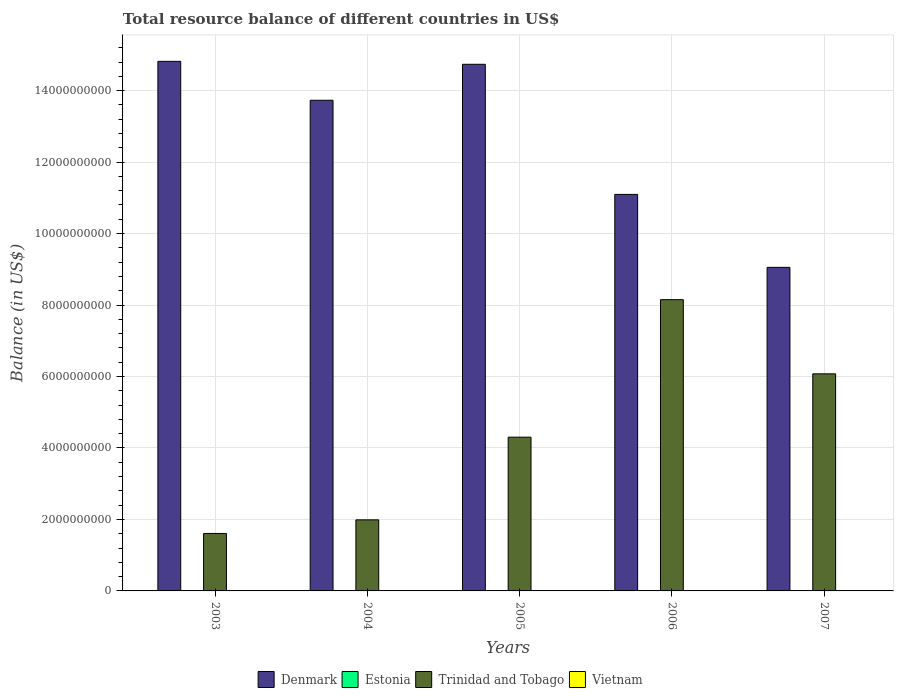How many groups of bars are there?
Offer a very short reply. 5. Are the number of bars per tick equal to the number of legend labels?
Your answer should be very brief. No. How many bars are there on the 1st tick from the right?
Give a very brief answer. 2. What is the total resource balance in Denmark in 2005?
Provide a succinct answer. 1.47e+1. Across all years, what is the minimum total resource balance in Vietnam?
Provide a succinct answer. 0. In which year was the total resource balance in Trinidad and Tobago maximum?
Your response must be concise. 2006. What is the total total resource balance in Denmark in the graph?
Keep it short and to the point. 6.34e+1. What is the difference between the total resource balance in Denmark in 2003 and that in 2004?
Make the answer very short. 1.09e+09. What is the difference between the total resource balance in Trinidad and Tobago in 2006 and the total resource balance in Denmark in 2004?
Your answer should be compact. -5.58e+09. What is the average total resource balance in Denmark per year?
Make the answer very short. 1.27e+1. In the year 2004, what is the difference between the total resource balance in Denmark and total resource balance in Trinidad and Tobago?
Keep it short and to the point. 1.17e+1. What is the ratio of the total resource balance in Trinidad and Tobago in 2003 to that in 2006?
Your response must be concise. 0.2. Is the total resource balance in Denmark in 2004 less than that in 2005?
Make the answer very short. Yes. What is the difference between the highest and the second highest total resource balance in Denmark?
Provide a succinct answer. 8.19e+07. What is the difference between the highest and the lowest total resource balance in Trinidad and Tobago?
Your answer should be compact. 6.54e+09. Is the sum of the total resource balance in Trinidad and Tobago in 2003 and 2005 greater than the maximum total resource balance in Estonia across all years?
Make the answer very short. Yes. Is it the case that in every year, the sum of the total resource balance in Denmark and total resource balance in Estonia is greater than the total resource balance in Trinidad and Tobago?
Make the answer very short. Yes. Are all the bars in the graph horizontal?
Your answer should be compact. No. What is the difference between two consecutive major ticks on the Y-axis?
Provide a succinct answer. 2.00e+09. Are the values on the major ticks of Y-axis written in scientific E-notation?
Offer a terse response. No. Where does the legend appear in the graph?
Offer a very short reply. Bottom center. How many legend labels are there?
Make the answer very short. 4. What is the title of the graph?
Offer a very short reply. Total resource balance of different countries in US$. Does "Serbia" appear as one of the legend labels in the graph?
Provide a short and direct response. No. What is the label or title of the X-axis?
Offer a very short reply. Years. What is the label or title of the Y-axis?
Keep it short and to the point. Balance (in US$). What is the Balance (in US$) of Denmark in 2003?
Your response must be concise. 1.48e+1. What is the Balance (in US$) of Trinidad and Tobago in 2003?
Offer a very short reply. 1.61e+09. What is the Balance (in US$) of Vietnam in 2003?
Offer a terse response. 0. What is the Balance (in US$) of Denmark in 2004?
Provide a short and direct response. 1.37e+1. What is the Balance (in US$) of Estonia in 2004?
Provide a succinct answer. 0. What is the Balance (in US$) in Trinidad and Tobago in 2004?
Keep it short and to the point. 1.99e+09. What is the Balance (in US$) in Denmark in 2005?
Provide a short and direct response. 1.47e+1. What is the Balance (in US$) of Estonia in 2005?
Offer a terse response. 0. What is the Balance (in US$) of Trinidad and Tobago in 2005?
Make the answer very short. 4.30e+09. What is the Balance (in US$) of Denmark in 2006?
Your response must be concise. 1.11e+1. What is the Balance (in US$) in Estonia in 2006?
Make the answer very short. 0. What is the Balance (in US$) of Trinidad and Tobago in 2006?
Offer a terse response. 8.15e+09. What is the Balance (in US$) of Denmark in 2007?
Your response must be concise. 9.05e+09. What is the Balance (in US$) in Estonia in 2007?
Make the answer very short. 0. What is the Balance (in US$) in Trinidad and Tobago in 2007?
Give a very brief answer. 6.08e+09. Across all years, what is the maximum Balance (in US$) of Denmark?
Give a very brief answer. 1.48e+1. Across all years, what is the maximum Balance (in US$) of Trinidad and Tobago?
Offer a very short reply. 8.15e+09. Across all years, what is the minimum Balance (in US$) in Denmark?
Offer a terse response. 9.05e+09. Across all years, what is the minimum Balance (in US$) in Trinidad and Tobago?
Give a very brief answer. 1.61e+09. What is the total Balance (in US$) of Denmark in the graph?
Offer a very short reply. 6.34e+1. What is the total Balance (in US$) of Estonia in the graph?
Offer a terse response. 0. What is the total Balance (in US$) in Trinidad and Tobago in the graph?
Ensure brevity in your answer.  2.21e+1. What is the total Balance (in US$) in Vietnam in the graph?
Ensure brevity in your answer.  0. What is the difference between the Balance (in US$) of Denmark in 2003 and that in 2004?
Your answer should be compact. 1.09e+09. What is the difference between the Balance (in US$) in Trinidad and Tobago in 2003 and that in 2004?
Your answer should be compact. -3.81e+08. What is the difference between the Balance (in US$) in Denmark in 2003 and that in 2005?
Make the answer very short. 8.19e+07. What is the difference between the Balance (in US$) of Trinidad and Tobago in 2003 and that in 2005?
Provide a succinct answer. -2.70e+09. What is the difference between the Balance (in US$) in Denmark in 2003 and that in 2006?
Make the answer very short. 3.72e+09. What is the difference between the Balance (in US$) of Trinidad and Tobago in 2003 and that in 2006?
Your answer should be very brief. -6.54e+09. What is the difference between the Balance (in US$) in Denmark in 2003 and that in 2007?
Your response must be concise. 5.77e+09. What is the difference between the Balance (in US$) of Trinidad and Tobago in 2003 and that in 2007?
Provide a short and direct response. -4.47e+09. What is the difference between the Balance (in US$) in Denmark in 2004 and that in 2005?
Offer a terse response. -1.01e+09. What is the difference between the Balance (in US$) in Trinidad and Tobago in 2004 and that in 2005?
Ensure brevity in your answer.  -2.31e+09. What is the difference between the Balance (in US$) of Denmark in 2004 and that in 2006?
Keep it short and to the point. 2.63e+09. What is the difference between the Balance (in US$) of Trinidad and Tobago in 2004 and that in 2006?
Provide a succinct answer. -6.16e+09. What is the difference between the Balance (in US$) in Denmark in 2004 and that in 2007?
Offer a very short reply. 4.68e+09. What is the difference between the Balance (in US$) in Trinidad and Tobago in 2004 and that in 2007?
Your answer should be very brief. -4.09e+09. What is the difference between the Balance (in US$) of Denmark in 2005 and that in 2006?
Your response must be concise. 3.64e+09. What is the difference between the Balance (in US$) in Trinidad and Tobago in 2005 and that in 2006?
Provide a succinct answer. -3.85e+09. What is the difference between the Balance (in US$) in Denmark in 2005 and that in 2007?
Provide a succinct answer. 5.68e+09. What is the difference between the Balance (in US$) in Trinidad and Tobago in 2005 and that in 2007?
Your answer should be compact. -1.77e+09. What is the difference between the Balance (in US$) in Denmark in 2006 and that in 2007?
Keep it short and to the point. 2.04e+09. What is the difference between the Balance (in US$) in Trinidad and Tobago in 2006 and that in 2007?
Provide a succinct answer. 2.08e+09. What is the difference between the Balance (in US$) of Denmark in 2003 and the Balance (in US$) of Trinidad and Tobago in 2004?
Provide a short and direct response. 1.28e+1. What is the difference between the Balance (in US$) of Denmark in 2003 and the Balance (in US$) of Trinidad and Tobago in 2005?
Your answer should be compact. 1.05e+1. What is the difference between the Balance (in US$) in Denmark in 2003 and the Balance (in US$) in Trinidad and Tobago in 2006?
Your response must be concise. 6.67e+09. What is the difference between the Balance (in US$) in Denmark in 2003 and the Balance (in US$) in Trinidad and Tobago in 2007?
Offer a very short reply. 8.74e+09. What is the difference between the Balance (in US$) in Denmark in 2004 and the Balance (in US$) in Trinidad and Tobago in 2005?
Give a very brief answer. 9.43e+09. What is the difference between the Balance (in US$) in Denmark in 2004 and the Balance (in US$) in Trinidad and Tobago in 2006?
Provide a succinct answer. 5.58e+09. What is the difference between the Balance (in US$) of Denmark in 2004 and the Balance (in US$) of Trinidad and Tobago in 2007?
Offer a terse response. 7.66e+09. What is the difference between the Balance (in US$) in Denmark in 2005 and the Balance (in US$) in Trinidad and Tobago in 2006?
Offer a very short reply. 6.59e+09. What is the difference between the Balance (in US$) in Denmark in 2005 and the Balance (in US$) in Trinidad and Tobago in 2007?
Offer a very short reply. 8.66e+09. What is the difference between the Balance (in US$) in Denmark in 2006 and the Balance (in US$) in Trinidad and Tobago in 2007?
Offer a very short reply. 5.02e+09. What is the average Balance (in US$) of Denmark per year?
Make the answer very short. 1.27e+1. What is the average Balance (in US$) of Trinidad and Tobago per year?
Offer a terse response. 4.43e+09. In the year 2003, what is the difference between the Balance (in US$) of Denmark and Balance (in US$) of Trinidad and Tobago?
Offer a very short reply. 1.32e+1. In the year 2004, what is the difference between the Balance (in US$) of Denmark and Balance (in US$) of Trinidad and Tobago?
Offer a terse response. 1.17e+1. In the year 2005, what is the difference between the Balance (in US$) in Denmark and Balance (in US$) in Trinidad and Tobago?
Provide a succinct answer. 1.04e+1. In the year 2006, what is the difference between the Balance (in US$) in Denmark and Balance (in US$) in Trinidad and Tobago?
Offer a terse response. 2.95e+09. In the year 2007, what is the difference between the Balance (in US$) of Denmark and Balance (in US$) of Trinidad and Tobago?
Your response must be concise. 2.98e+09. What is the ratio of the Balance (in US$) of Denmark in 2003 to that in 2004?
Offer a terse response. 1.08. What is the ratio of the Balance (in US$) of Trinidad and Tobago in 2003 to that in 2004?
Your answer should be very brief. 0.81. What is the ratio of the Balance (in US$) of Denmark in 2003 to that in 2005?
Offer a very short reply. 1.01. What is the ratio of the Balance (in US$) in Trinidad and Tobago in 2003 to that in 2005?
Keep it short and to the point. 0.37. What is the ratio of the Balance (in US$) of Denmark in 2003 to that in 2006?
Provide a short and direct response. 1.34. What is the ratio of the Balance (in US$) in Trinidad and Tobago in 2003 to that in 2006?
Keep it short and to the point. 0.2. What is the ratio of the Balance (in US$) of Denmark in 2003 to that in 2007?
Your response must be concise. 1.64. What is the ratio of the Balance (in US$) in Trinidad and Tobago in 2003 to that in 2007?
Offer a terse response. 0.26. What is the ratio of the Balance (in US$) in Denmark in 2004 to that in 2005?
Keep it short and to the point. 0.93. What is the ratio of the Balance (in US$) in Trinidad and Tobago in 2004 to that in 2005?
Your response must be concise. 0.46. What is the ratio of the Balance (in US$) in Denmark in 2004 to that in 2006?
Offer a terse response. 1.24. What is the ratio of the Balance (in US$) of Trinidad and Tobago in 2004 to that in 2006?
Offer a terse response. 0.24. What is the ratio of the Balance (in US$) in Denmark in 2004 to that in 2007?
Your answer should be very brief. 1.52. What is the ratio of the Balance (in US$) in Trinidad and Tobago in 2004 to that in 2007?
Give a very brief answer. 0.33. What is the ratio of the Balance (in US$) of Denmark in 2005 to that in 2006?
Your answer should be compact. 1.33. What is the ratio of the Balance (in US$) in Trinidad and Tobago in 2005 to that in 2006?
Keep it short and to the point. 0.53. What is the ratio of the Balance (in US$) of Denmark in 2005 to that in 2007?
Keep it short and to the point. 1.63. What is the ratio of the Balance (in US$) in Trinidad and Tobago in 2005 to that in 2007?
Give a very brief answer. 0.71. What is the ratio of the Balance (in US$) of Denmark in 2006 to that in 2007?
Your answer should be compact. 1.23. What is the ratio of the Balance (in US$) in Trinidad and Tobago in 2006 to that in 2007?
Provide a succinct answer. 1.34. What is the difference between the highest and the second highest Balance (in US$) of Denmark?
Ensure brevity in your answer.  8.19e+07. What is the difference between the highest and the second highest Balance (in US$) in Trinidad and Tobago?
Your answer should be very brief. 2.08e+09. What is the difference between the highest and the lowest Balance (in US$) of Denmark?
Offer a very short reply. 5.77e+09. What is the difference between the highest and the lowest Balance (in US$) of Trinidad and Tobago?
Your response must be concise. 6.54e+09. 